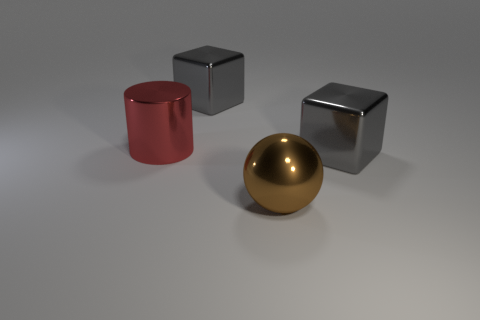The big block that is on the left side of the big gray block that is on the right side of the brown metal object is made of what material?
Ensure brevity in your answer.  Metal. What is the shape of the brown shiny thing?
Give a very brief answer. Sphere. How many brown shiny objects have the same size as the red cylinder?
Give a very brief answer. 1. There is a large block that is behind the red cylinder; is there a shiny ball that is right of it?
Make the answer very short. Yes. What number of brown objects are either big shiny spheres or large metal cubes?
Offer a very short reply. 1. The large metallic cylinder has what color?
Give a very brief answer. Red. The cylinder that is made of the same material as the large sphere is what size?
Make the answer very short. Large. How many other metallic things are the same shape as the large brown object?
Give a very brief answer. 0. There is a gray object that is right of the big cube on the left side of the ball; what is its size?
Make the answer very short. Large. Is there a blue cylinder that has the same material as the big red cylinder?
Give a very brief answer. No. 